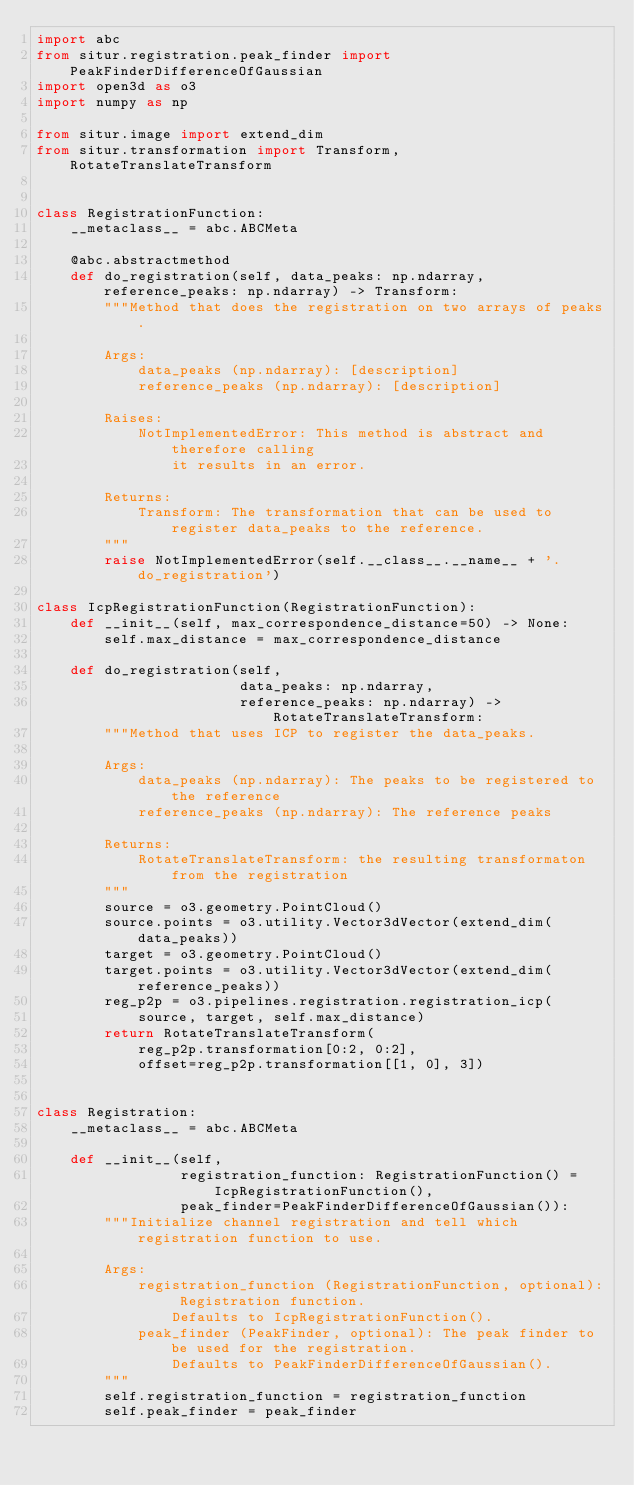<code> <loc_0><loc_0><loc_500><loc_500><_Python_>import abc
from situr.registration.peak_finder import PeakFinderDifferenceOfGaussian
import open3d as o3
import numpy as np

from situr.image import extend_dim
from situr.transformation import Transform, RotateTranslateTransform


class RegistrationFunction:
    __metaclass__ = abc.ABCMeta

    @abc.abstractmethod
    def do_registration(self, data_peaks: np.ndarray, reference_peaks: np.ndarray) -> Transform:
        """Method that does the registration on two arrays of peaks.

        Args:
            data_peaks (np.ndarray): [description]
            reference_peaks (np.ndarray): [description]

        Raises:
            NotImplementedError: This method is abstract and therefore calling
                it results in an error.

        Returns:
            Transform: The transformation that can be used to register data_peaks to the reference.
        """
        raise NotImplementedError(self.__class__.__name__ + '.do_registration')

class IcpRegistrationFunction(RegistrationFunction):
    def __init__(self, max_correspondence_distance=50) -> None:
        self.max_distance = max_correspondence_distance

    def do_registration(self,
                        data_peaks: np.ndarray,
                        reference_peaks: np.ndarray) -> RotateTranslateTransform:
        """Method that uses ICP to register the data_peaks.

        Args:
            data_peaks (np.ndarray): The peaks to be registered to the reference
            reference_peaks (np.ndarray): The reference peaks

        Returns:
            RotateTranslateTransform: the resulting transformaton from the registration
        """
        source = o3.geometry.PointCloud()
        source.points = o3.utility.Vector3dVector(extend_dim(data_peaks))
        target = o3.geometry.PointCloud()
        target.points = o3.utility.Vector3dVector(extend_dim(reference_peaks))
        reg_p2p = o3.pipelines.registration.registration_icp(
            source, target, self.max_distance)
        return RotateTranslateTransform(
            reg_p2p.transformation[0:2, 0:2],
            offset=reg_p2p.transformation[[1, 0], 3])


class Registration:
    __metaclass__ = abc.ABCMeta

    def __init__(self,
                 registration_function: RegistrationFunction() = IcpRegistrationFunction(),
                 peak_finder=PeakFinderDifferenceOfGaussian()):
        """Initialize channel registration and tell which registration function to use.

        Args:
            registration_function (RegistrationFunction, optional): Registration function.
                Defaults to IcpRegistrationFunction().
            peak_finder (PeakFinder, optional): The peak finder to be used for the registration.
                Defaults to PeakFinderDifferenceOfGaussian().
        """
        self.registration_function = registration_function
        self.peak_finder = peak_finder
</code> 